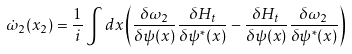<formula> <loc_0><loc_0><loc_500><loc_500>\dot { \omega } _ { 2 } ( x _ { 2 } ) = \frac { 1 } { i } \int d x \left ( \frac { \delta \omega _ { 2 } } { \delta \psi ( x ) } \frac { \delta H _ { t } } { \delta \psi ^ { * } ( x ) } - \frac { \delta H _ { t } } { \delta \psi ( x ) } \frac { \delta \omega _ { 2 } } { \delta \psi ^ { * } ( x ) } \right )</formula> 